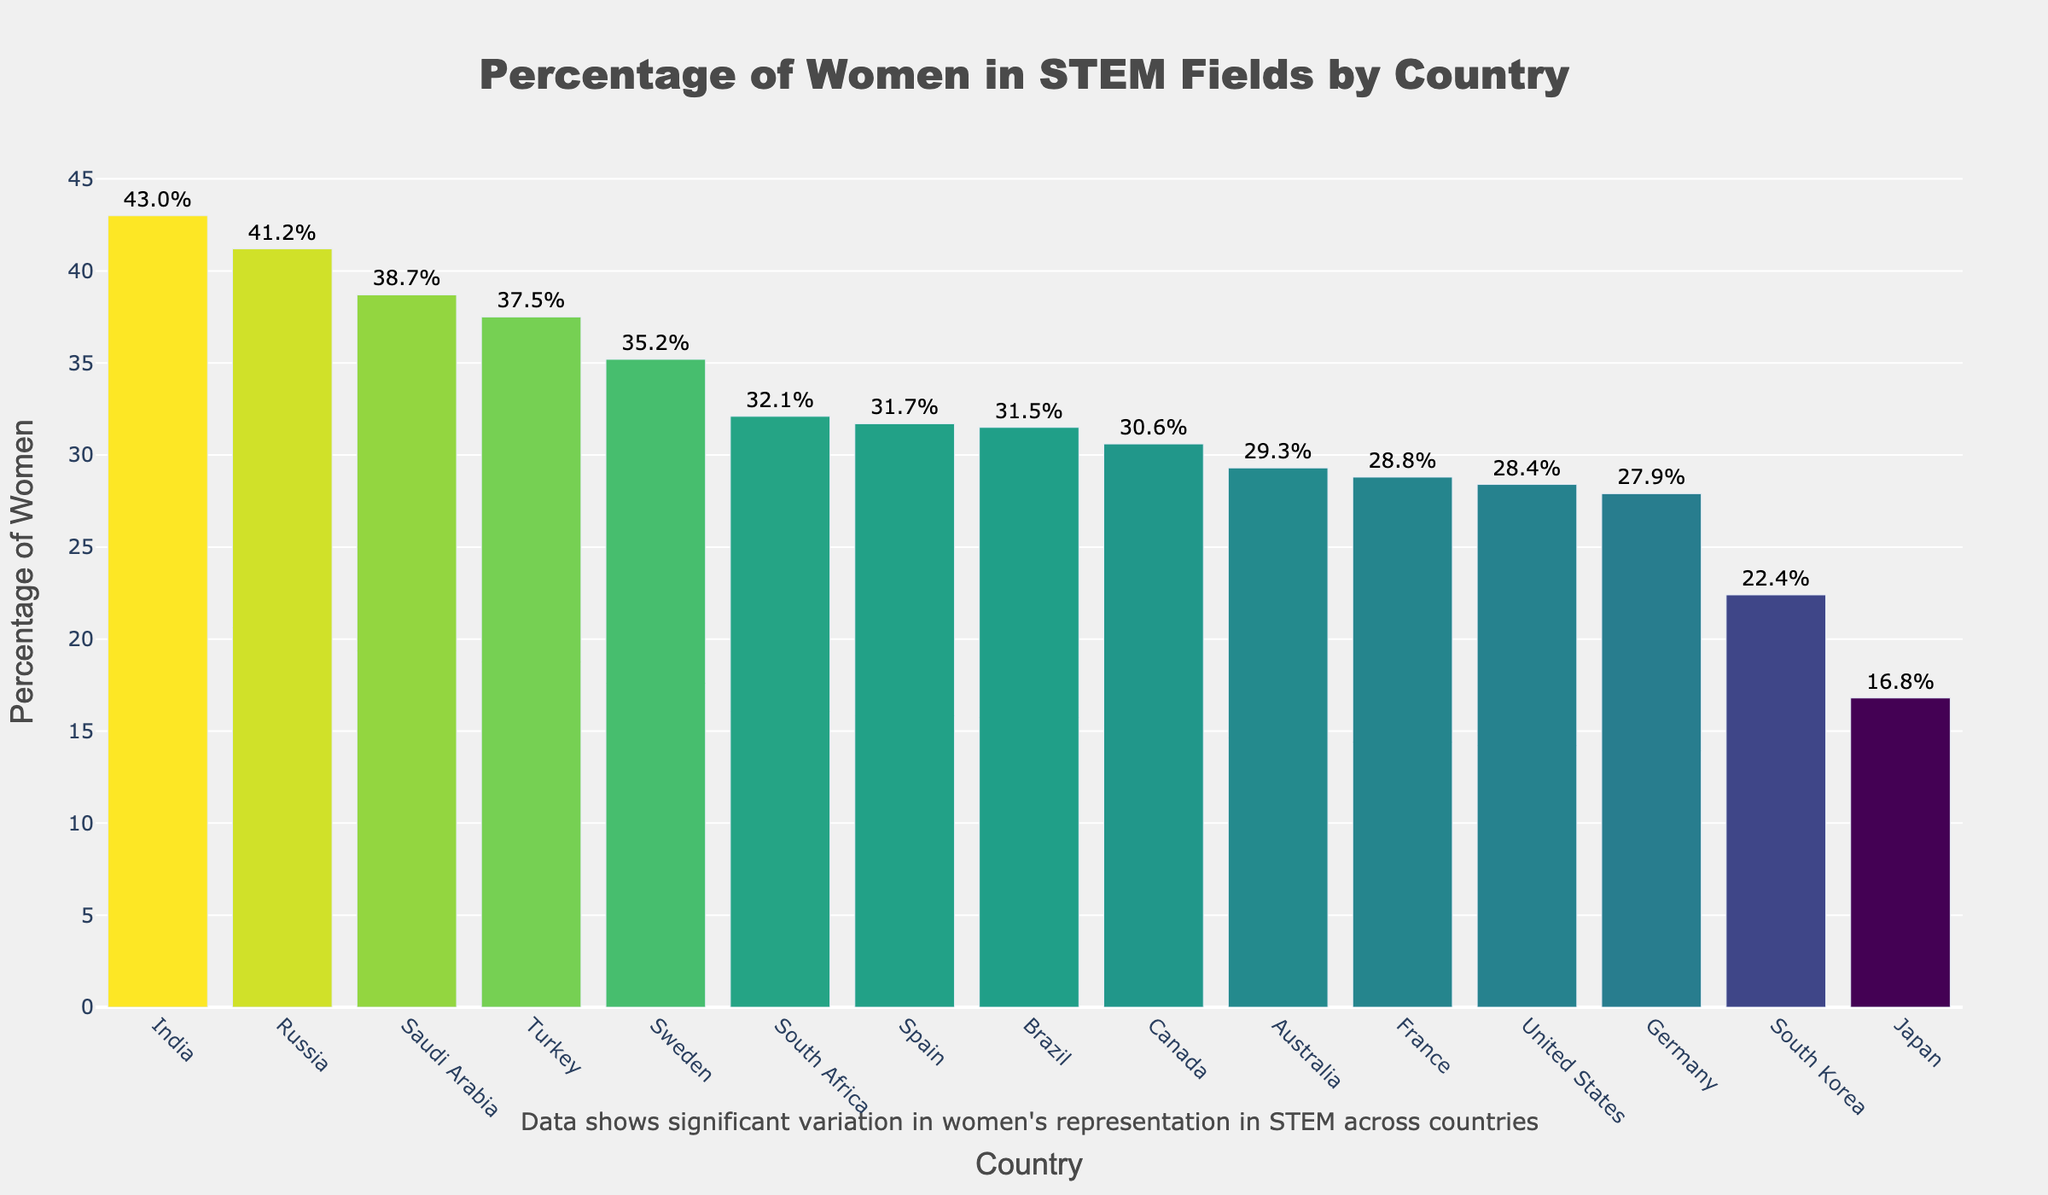What's the range of percentages of women in STEM fields across the countries? To find the range, subtract the smallest percentage from the largest percentage in the dataset. The largest percentage is 43.0% (India) and the smallest percentage is 16.8% (Japan). So, the range is 43.0 - 16.8 = 26.2.
Answer: 26.2 Which country has the second highest percentage of women in STEM fields? The bar chart is ordered by percentage in descending order, making it easy to identify the second highest. India is the highest with 43.0%, followed by Saudi Arabia with 38.7%.
Answer: Saudi Arabia How much more is the percentage of women in STEM in Russia compared to Brazil? Russia has 41.2% and Brazil has 31.5%. Subtract Brazil's percentage from Russia's: 41.2 - 31.5 = 9.7.
Answer: 9.7 What is the average percentage of women in STEM fields across all listed countries? Add up all the percentages and divide by the number of countries (15). Sum = 35.2 + 28.4 + 16.8 + 43.0 + 32.1 + 31.5 + 27.9 + 29.3 + 38.7 + 41.2 + 30.6 + 28.8 + 22.4 + 31.7 + 37.5 = 445.2. Divide by 15: 445.2 / 15 = 29.68.
Answer: 29.68 Which country shows a percentage closest to 30%? Identifying bars around 30%, Canada shows a percentage of 30.6%, which is the closest to 30%.
Answer: Canada Between which countries is the largest difference in percentages, and what is this difference? The largest difference will be between the highest (India, 43.0%) and the lowest (Japan, 16.8%). Subtract the lowest from the highest: 43.0 - 16.8 = 26.2.
Answer: India and Japan, 26.2 How does the percentage of women in STEM in Germany compare to that in France? Germany has 27.9% and France has 28.8%. Since 28.8 > 27.9, France has a slightly higher percentage of women in STEM than Germany.
Answer: France has a higher percentage What is the median percentage of women in STEM fields across all listed countries? To find the median, list the percentages in ascending order and identify the middle value. Sorted values are: 16.8, 22.4, 27.9, 28.4, 28.8, 29.3, 30.6, 31.5, 31.7, 32.1, 35.2, 37.5, 38.7, 41.2, 43.0. The middle value is the 8th value: 30.6.
Answer: 30.6 In which three countries is the representation of women in STEM over 35%? Identify countries with bars over the 35% mark. These are India (43.0%), Saudi Arabia (38.7%), and Russia (41.2%), and Turkey (37.5%).
Answer: India, Saudi Arabia, Russia, and Turkey 